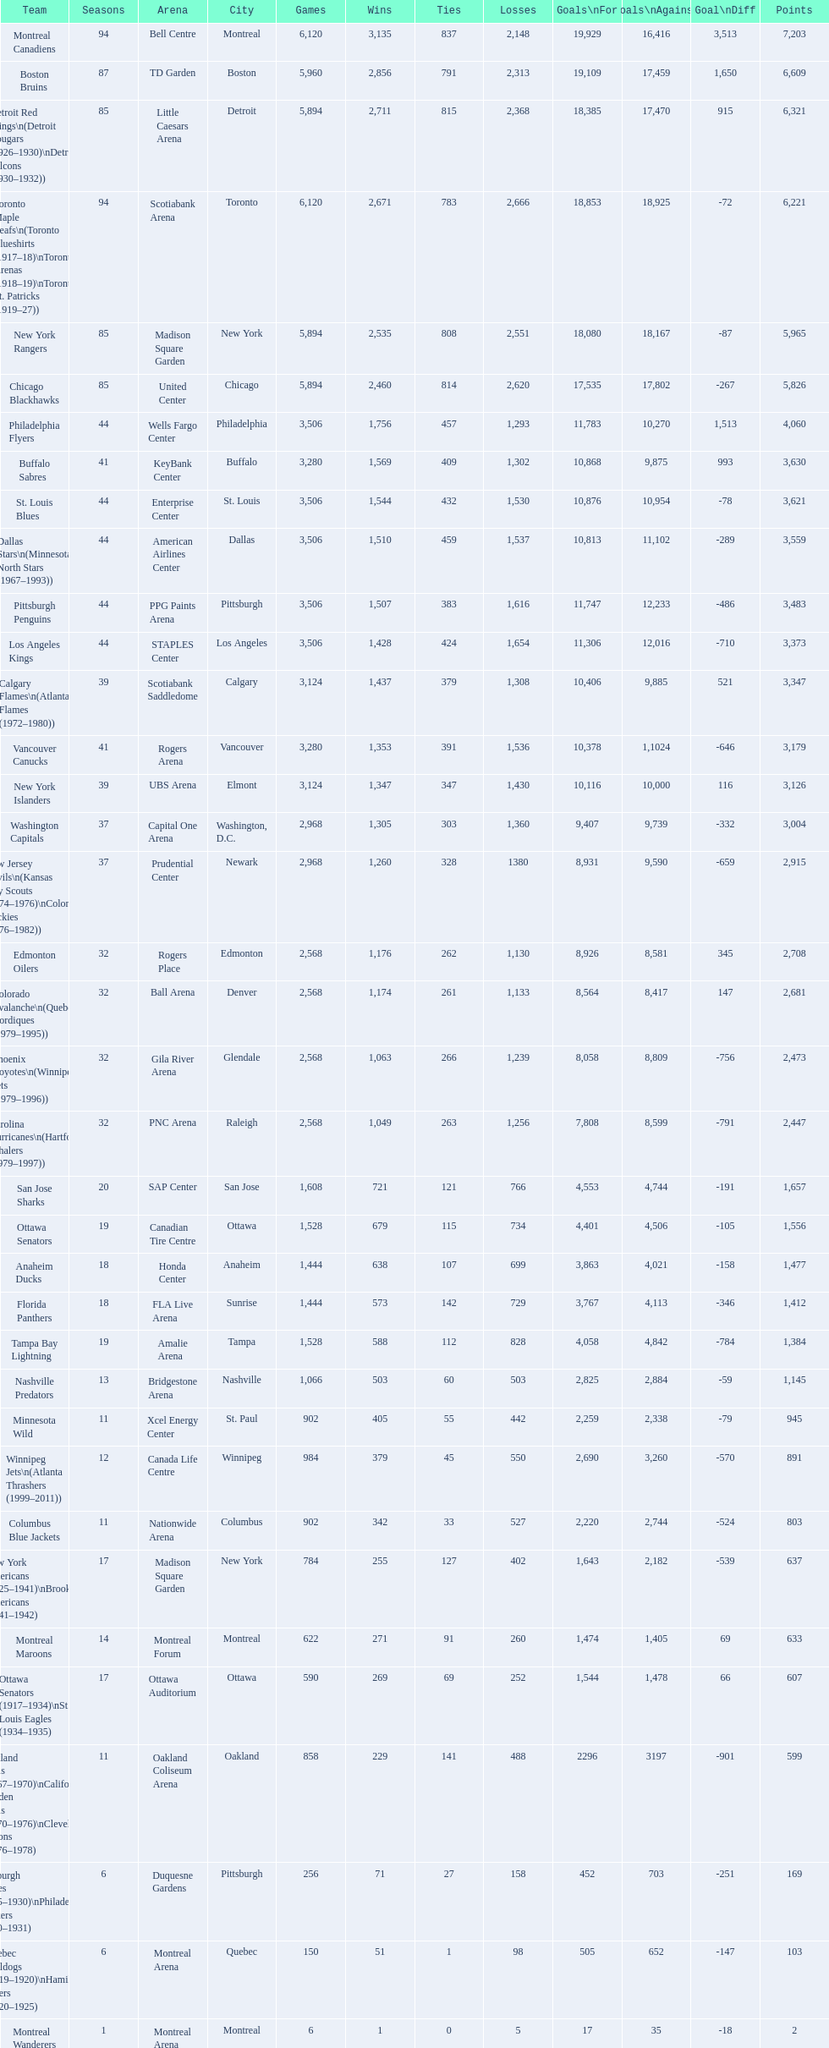How many teams have won more than 1,500 games? 11. 